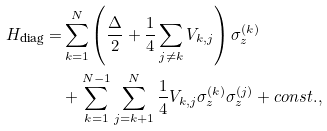Convert formula to latex. <formula><loc_0><loc_0><loc_500><loc_500>H _ { \text {diag} } = & \sum _ { k = 1 } ^ { N } \left ( \frac { \Delta } { 2 } + \frac { 1 } { 4 } \sum _ { j \neq k } V _ { k , j } \right ) \sigma ^ { ( k ) } _ { z } \\ & + \sum _ { k = 1 } ^ { N - 1 } \sum _ { j = k + 1 } ^ { N } \frac { 1 } { 4 } V _ { k , j } \sigma ^ { ( k ) } _ { z } \sigma ^ { ( j ) } _ { z } + c o n s t . ,</formula> 